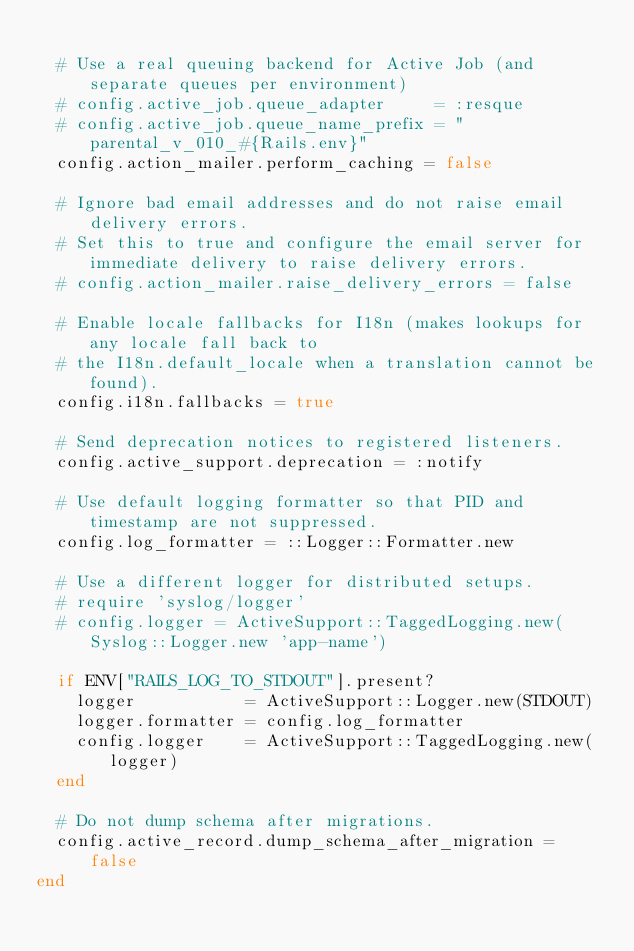<code> <loc_0><loc_0><loc_500><loc_500><_Ruby_>
  # Use a real queuing backend for Active Job (and separate queues per environment)
  # config.active_job.queue_adapter     = :resque
  # config.active_job.queue_name_prefix = "parental_v_010_#{Rails.env}"
  config.action_mailer.perform_caching = false

  # Ignore bad email addresses and do not raise email delivery errors.
  # Set this to true and configure the email server for immediate delivery to raise delivery errors.
  # config.action_mailer.raise_delivery_errors = false

  # Enable locale fallbacks for I18n (makes lookups for any locale fall back to
  # the I18n.default_locale when a translation cannot be found).
  config.i18n.fallbacks = true

  # Send deprecation notices to registered listeners.
  config.active_support.deprecation = :notify

  # Use default logging formatter so that PID and timestamp are not suppressed.
  config.log_formatter = ::Logger::Formatter.new

  # Use a different logger for distributed setups.
  # require 'syslog/logger'
  # config.logger = ActiveSupport::TaggedLogging.new(Syslog::Logger.new 'app-name')

  if ENV["RAILS_LOG_TO_STDOUT"].present?
    logger           = ActiveSupport::Logger.new(STDOUT)
    logger.formatter = config.log_formatter
    config.logger    = ActiveSupport::TaggedLogging.new(logger)
  end

  # Do not dump schema after migrations.
  config.active_record.dump_schema_after_migration = false
end
</code> 